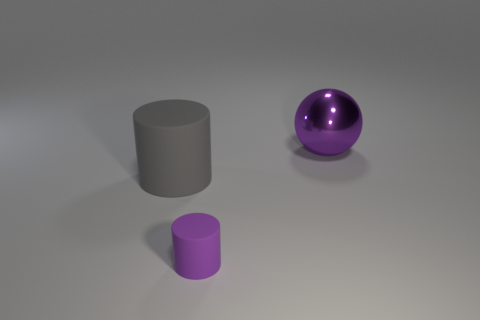Are there more small purple matte things than large green spheres?
Provide a short and direct response. Yes. Is the material of the purple thing to the left of the shiny thing the same as the big object to the right of the big gray thing?
Ensure brevity in your answer.  No. What is the material of the tiny cylinder?
Provide a succinct answer. Rubber. Is the number of rubber cylinders in front of the big purple metal thing greater than the number of large purple metal cubes?
Provide a succinct answer. Yes. How many things are right of the matte object that is on the left side of the purple object that is left of the ball?
Your answer should be compact. 2. The thing that is behind the purple matte thing and in front of the shiny object is made of what material?
Give a very brief answer. Rubber. The small thing is what color?
Make the answer very short. Purple. Is the number of big gray rubber cylinders to the left of the small cylinder greater than the number of shiny objects in front of the large sphere?
Offer a terse response. Yes. The big object to the right of the gray object is what color?
Offer a very short reply. Purple. There is a cylinder to the right of the big gray thing; is its size the same as the purple object that is behind the big gray rubber cylinder?
Give a very brief answer. No. 